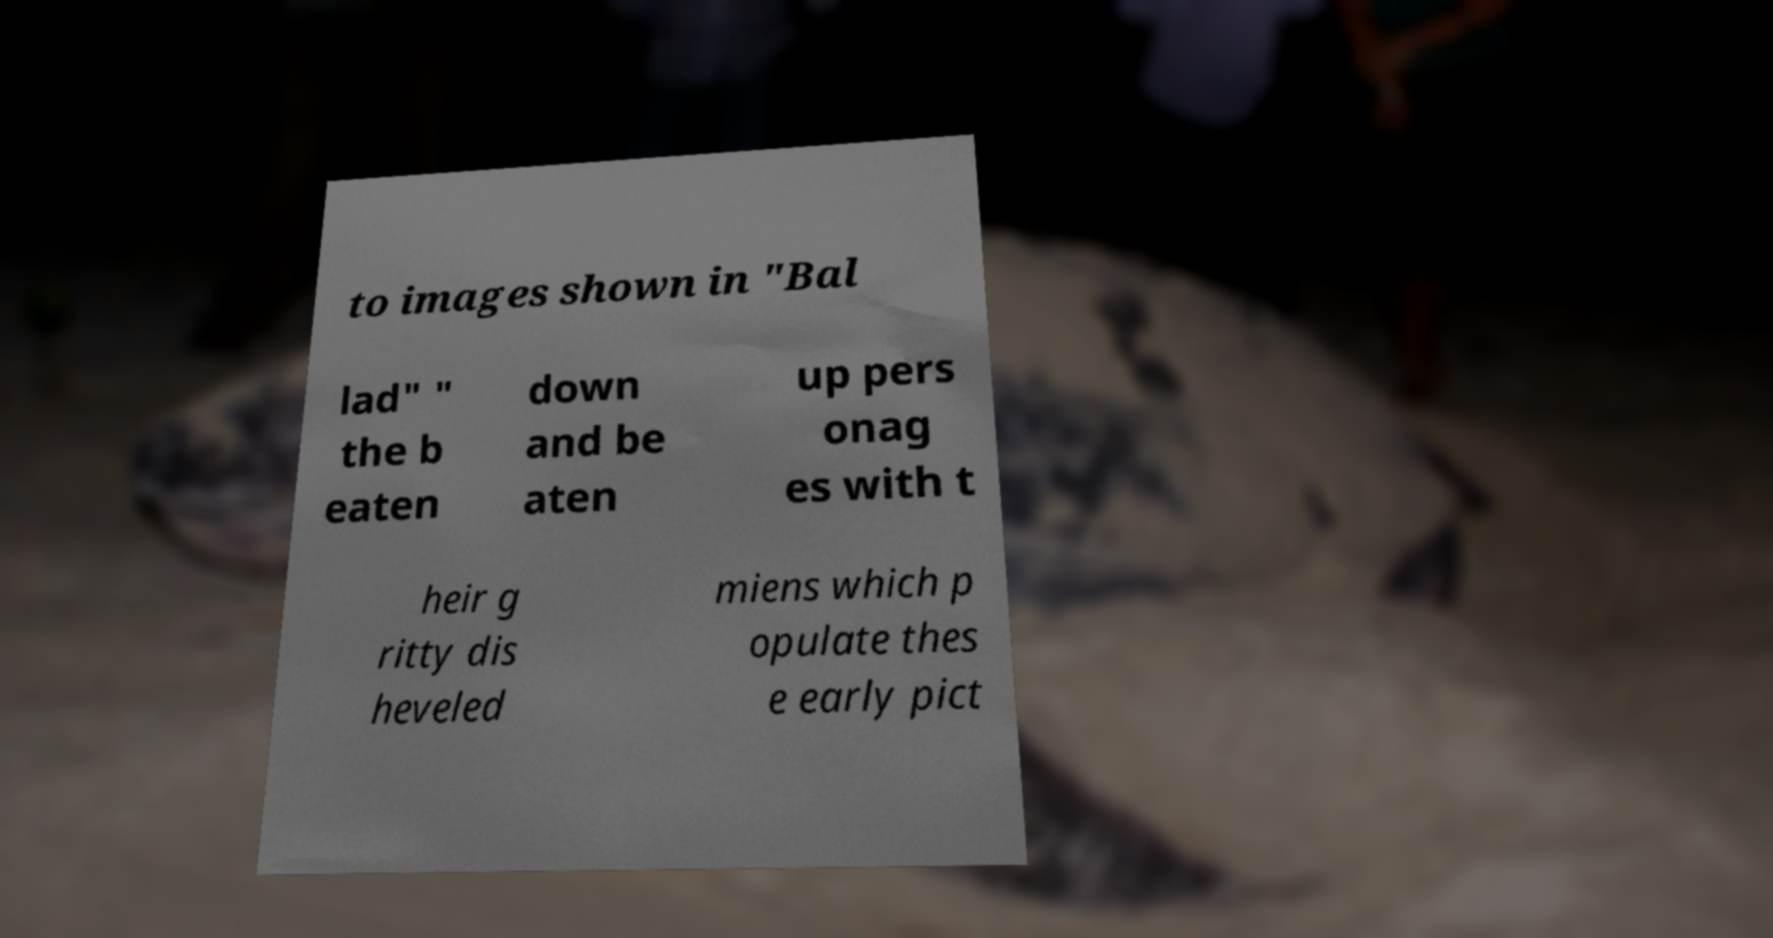Please read and relay the text visible in this image. What does it say? to images shown in "Bal lad" " the b eaten down and be aten up pers onag es with t heir g ritty dis heveled miens which p opulate thes e early pict 